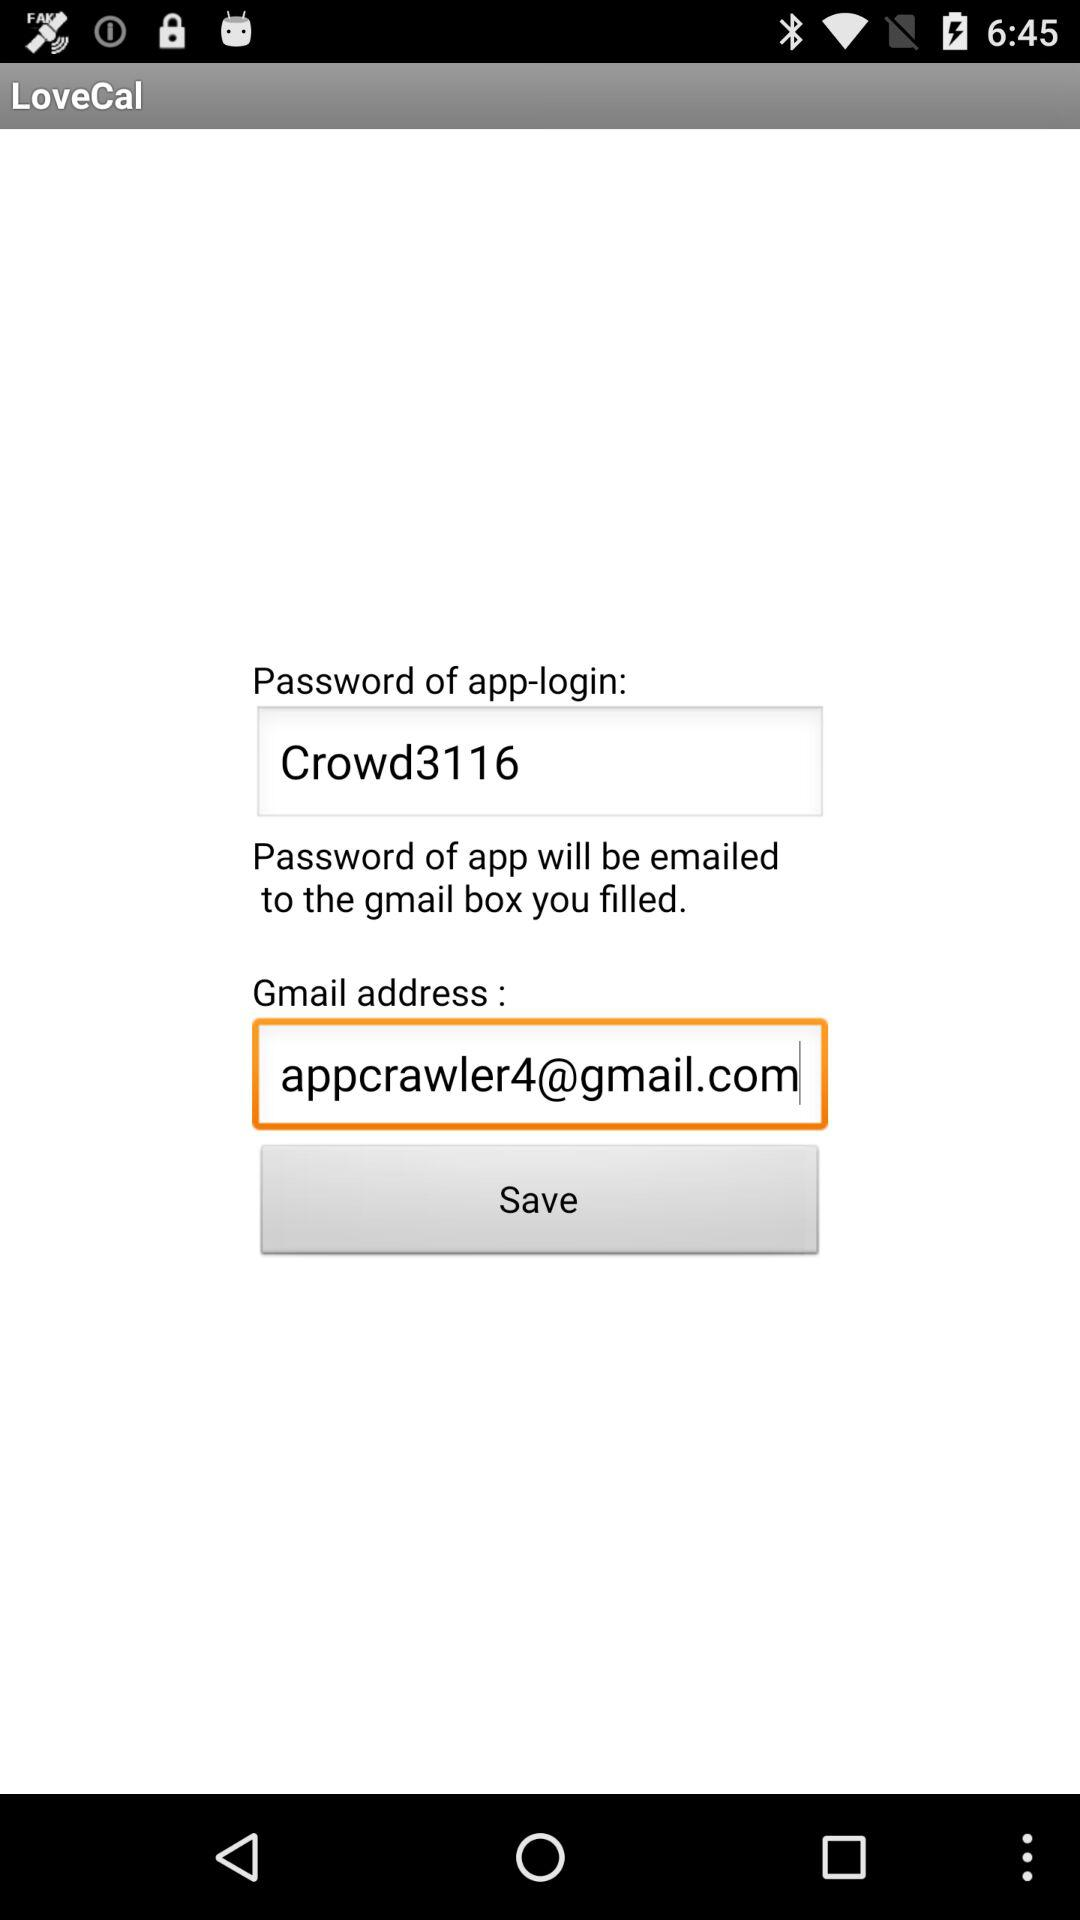What is the password for logging into the application? The password is "Crowd3116". 